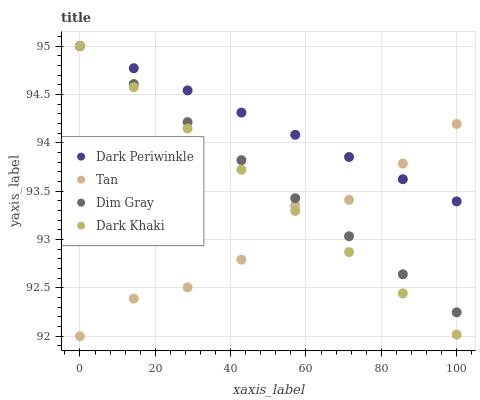Does Tan have the minimum area under the curve?
Answer yes or no. Yes. Does Dark Periwinkle have the maximum area under the curve?
Answer yes or no. Yes. Does Dim Gray have the minimum area under the curve?
Answer yes or no. No. Does Dim Gray have the maximum area under the curve?
Answer yes or no. No. Is Dark Periwinkle the smoothest?
Answer yes or no. Yes. Is Tan the roughest?
Answer yes or no. Yes. Is Dim Gray the smoothest?
Answer yes or no. No. Is Dim Gray the roughest?
Answer yes or no. No. Does Tan have the lowest value?
Answer yes or no. Yes. Does Dim Gray have the lowest value?
Answer yes or no. No. Does Dark Periwinkle have the highest value?
Answer yes or no. Yes. Does Tan have the highest value?
Answer yes or no. No. Does Dim Gray intersect Tan?
Answer yes or no. Yes. Is Dim Gray less than Tan?
Answer yes or no. No. Is Dim Gray greater than Tan?
Answer yes or no. No. 